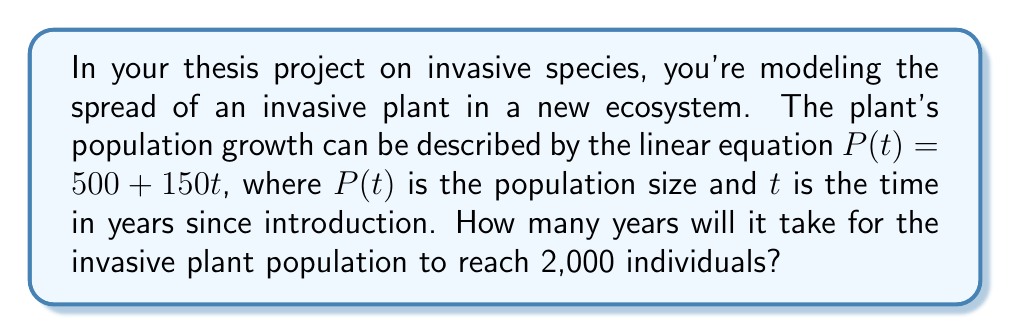Could you help me with this problem? Let's approach this step-by-step:

1) We're given the linear equation: $P(t) = 500 + 150t$

2) We want to find $t$ when $P(t) = 2000$. So, we can set up the equation:

   $2000 = 500 + 150t$

3) Subtract 500 from both sides:

   $1500 = 150t$

4) Divide both sides by 150:

   $\frac{1500}{150} = t$

5) Simplify:

   $10 = t$

Therefore, it will take 10 years for the invasive plant population to reach 2,000 individuals.
Answer: 10 years 